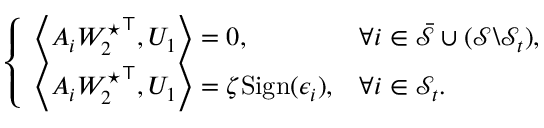<formula> <loc_0><loc_0><loc_500><loc_500>\begin{array} { r } { \left \{ \begin{array} { l l } { \left \langle A _ { i } { W _ { 2 } ^ { ^ { * } } } ^ { \top } , U _ { 1 } \right \rangle = 0 , } & { \forall i \in \bar { \mathcal { S } } \cup ( \mathcal { S } \ \mathcal { S } _ { t } ) , } \\ { \left \langle A _ { i } { W _ { 2 } ^ { ^ { * } } } ^ { \top } , U _ { 1 } \right \rangle = \zeta S i g n ( \epsilon _ { i } ) , } & { \forall i \in { \mathcal { S } _ { t } } . } \end{array} } \end{array}</formula> 